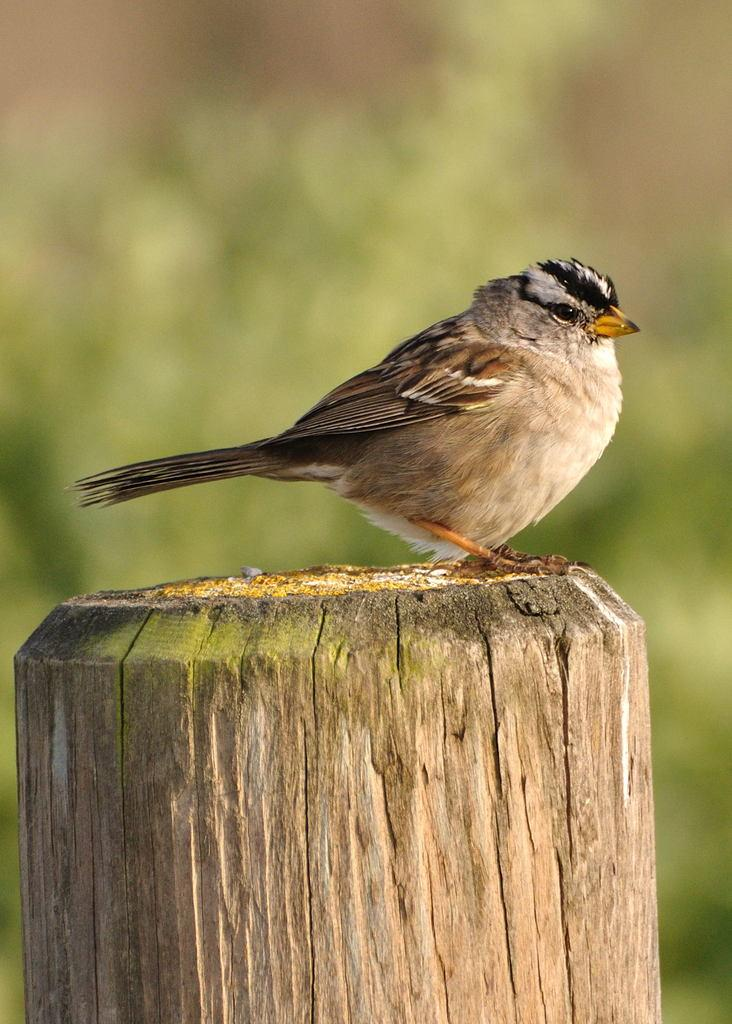What type of animal is in the image? There is a bird in the image. What is the bird perched on? The bird is on a wooden stick. What color is the background of the image? The background of the image is green. How is the background of the image depicted? The background is blurred. What type of cup is being used to fly the bird in the image? There is no cup present in the image, and the bird is not being flown. 